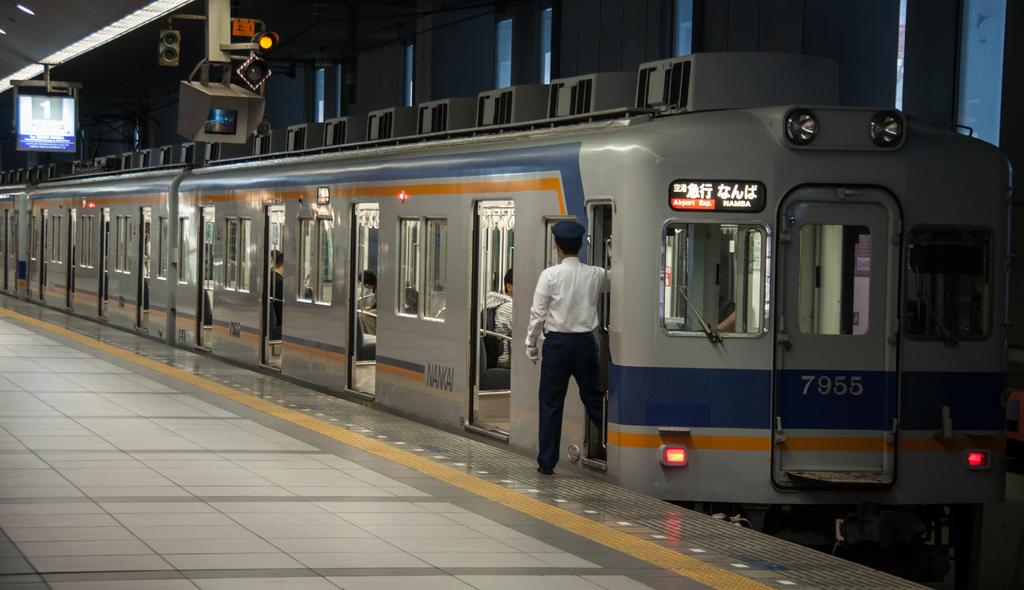What can be seen in the image besides people? There is a train, a screen, a traffic signal, and buildings visible in the image. What mode of transportation is present in the image? There is a train in the image. What type of signaling device is present in the image? There is a traffic signal in the image. Can you describe the clothing of one of the people in the image? A person is wearing a white color shirt in the image. How many bridges are visible in the image? There are no bridges present in the image. What type of wheel is used by the train in the image? The image does not show the train's wheels, so it cannot be determined from the image. 